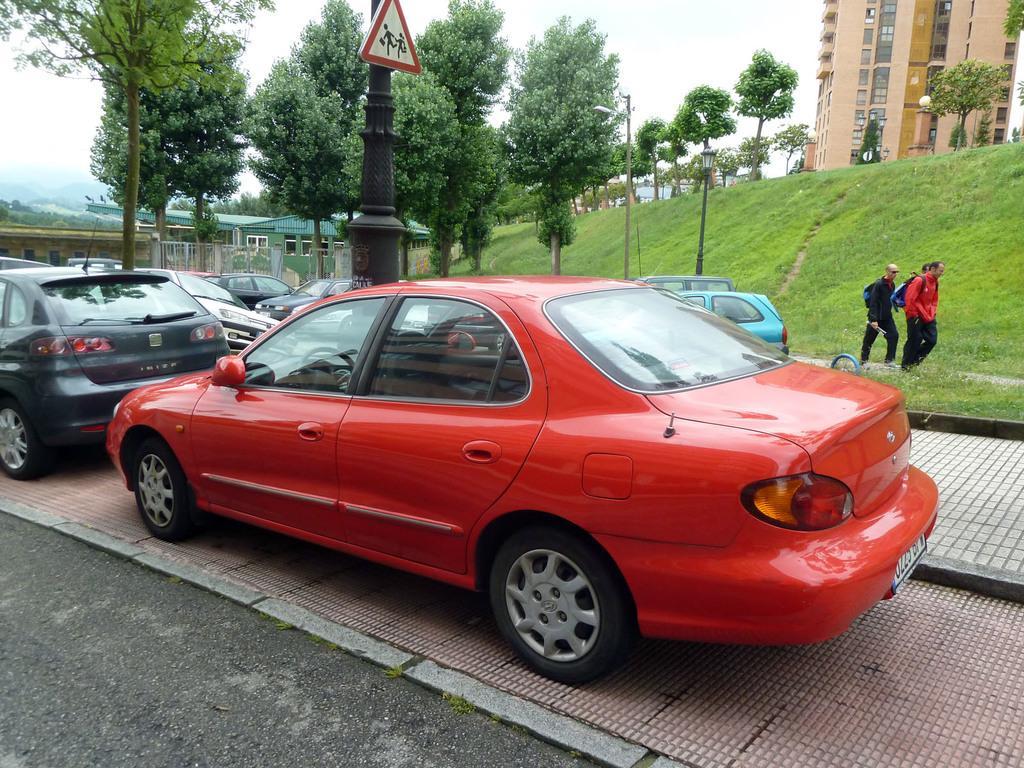Please provide a concise description of this image. This picture is clicked outside. In the center we can see the group of cats seems to be parked on the ground and we can see the two persons wearing backpacks and walking on the ground and we can see the green grass, trees, poles, lights and some other objects. In the background we can see the sky, buildings, trees and some other objects. 